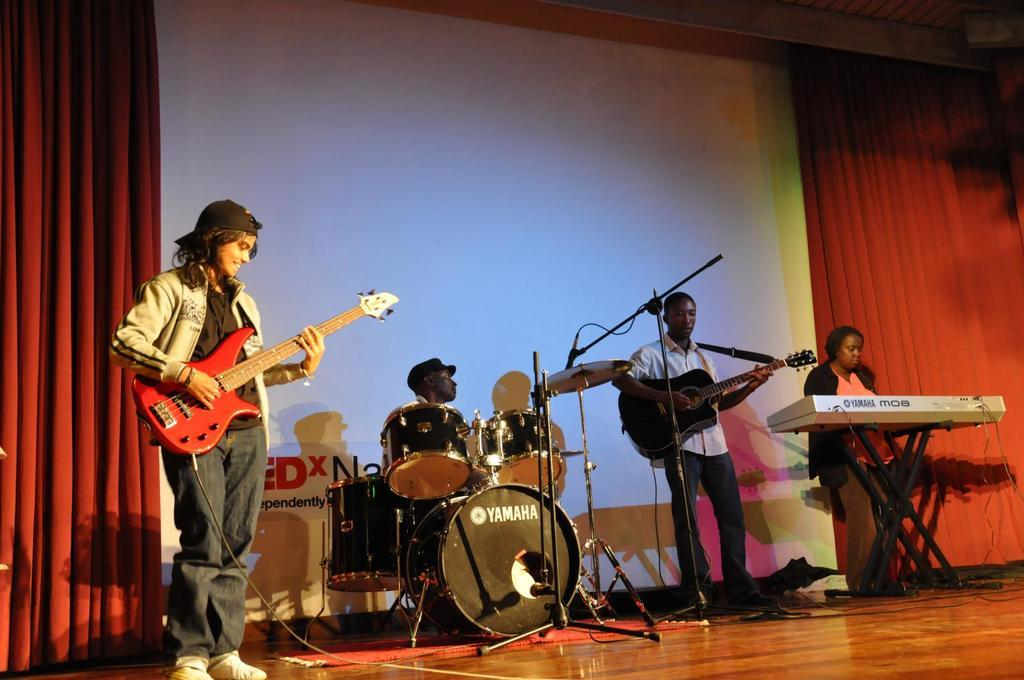How many people are present in the image? There are four people in the image. What are three of the people doing in the image? Three of the people are holding musical instruments. Can you describe the woman's position in the image? A woman is near a keyboard. What can be seen in the background of the image? There is a red curtain in the background of the image. What type of wound can be seen on the man playing the guitar in the image? There is no wound visible on any of the people in the image. Can you tell me if the store in the background is open or closed? There is no store present in the image; it features a group of people with musical instruments and a red curtain in the background. 